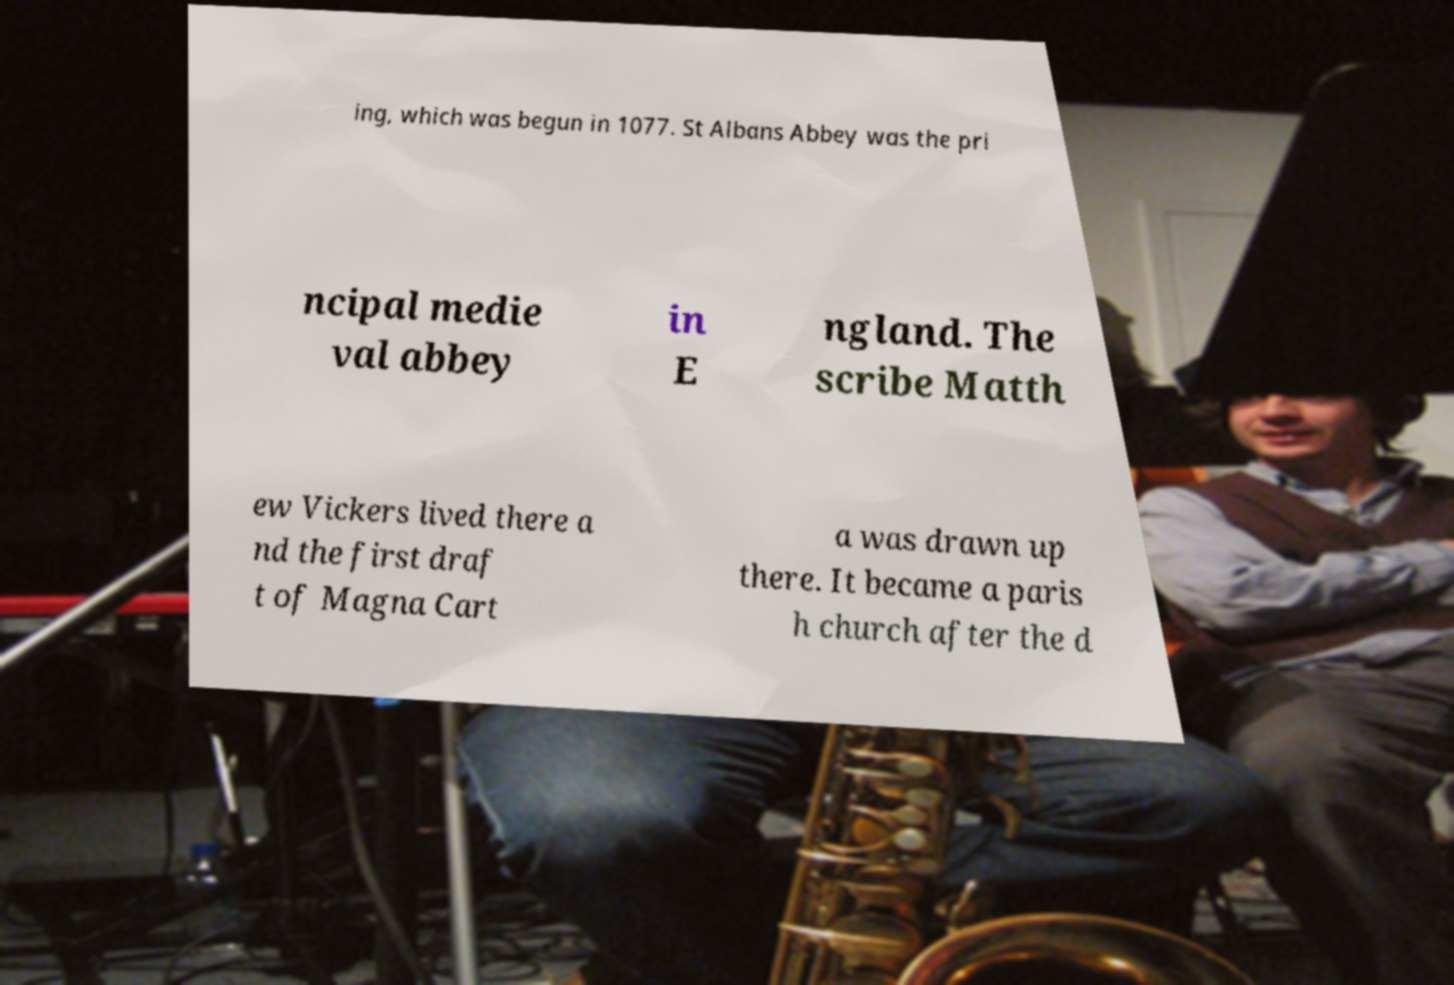Could you assist in decoding the text presented in this image and type it out clearly? ing, which was begun in 1077. St Albans Abbey was the pri ncipal medie val abbey in E ngland. The scribe Matth ew Vickers lived there a nd the first draf t of Magna Cart a was drawn up there. It became a paris h church after the d 